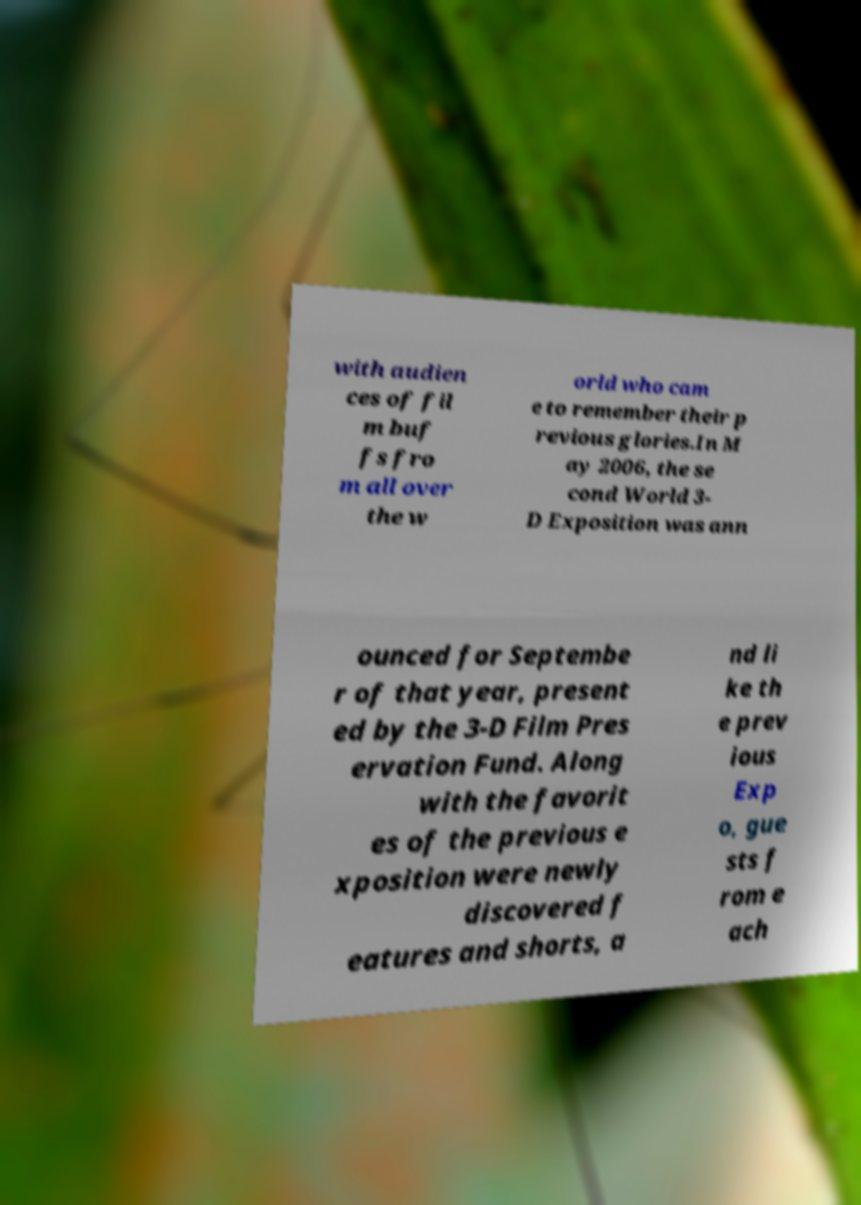Can you read and provide the text displayed in the image?This photo seems to have some interesting text. Can you extract and type it out for me? with audien ces of fil m buf fs fro m all over the w orld who cam e to remember their p revious glories.In M ay 2006, the se cond World 3- D Exposition was ann ounced for Septembe r of that year, present ed by the 3-D Film Pres ervation Fund. Along with the favorit es of the previous e xposition were newly discovered f eatures and shorts, a nd li ke th e prev ious Exp o, gue sts f rom e ach 